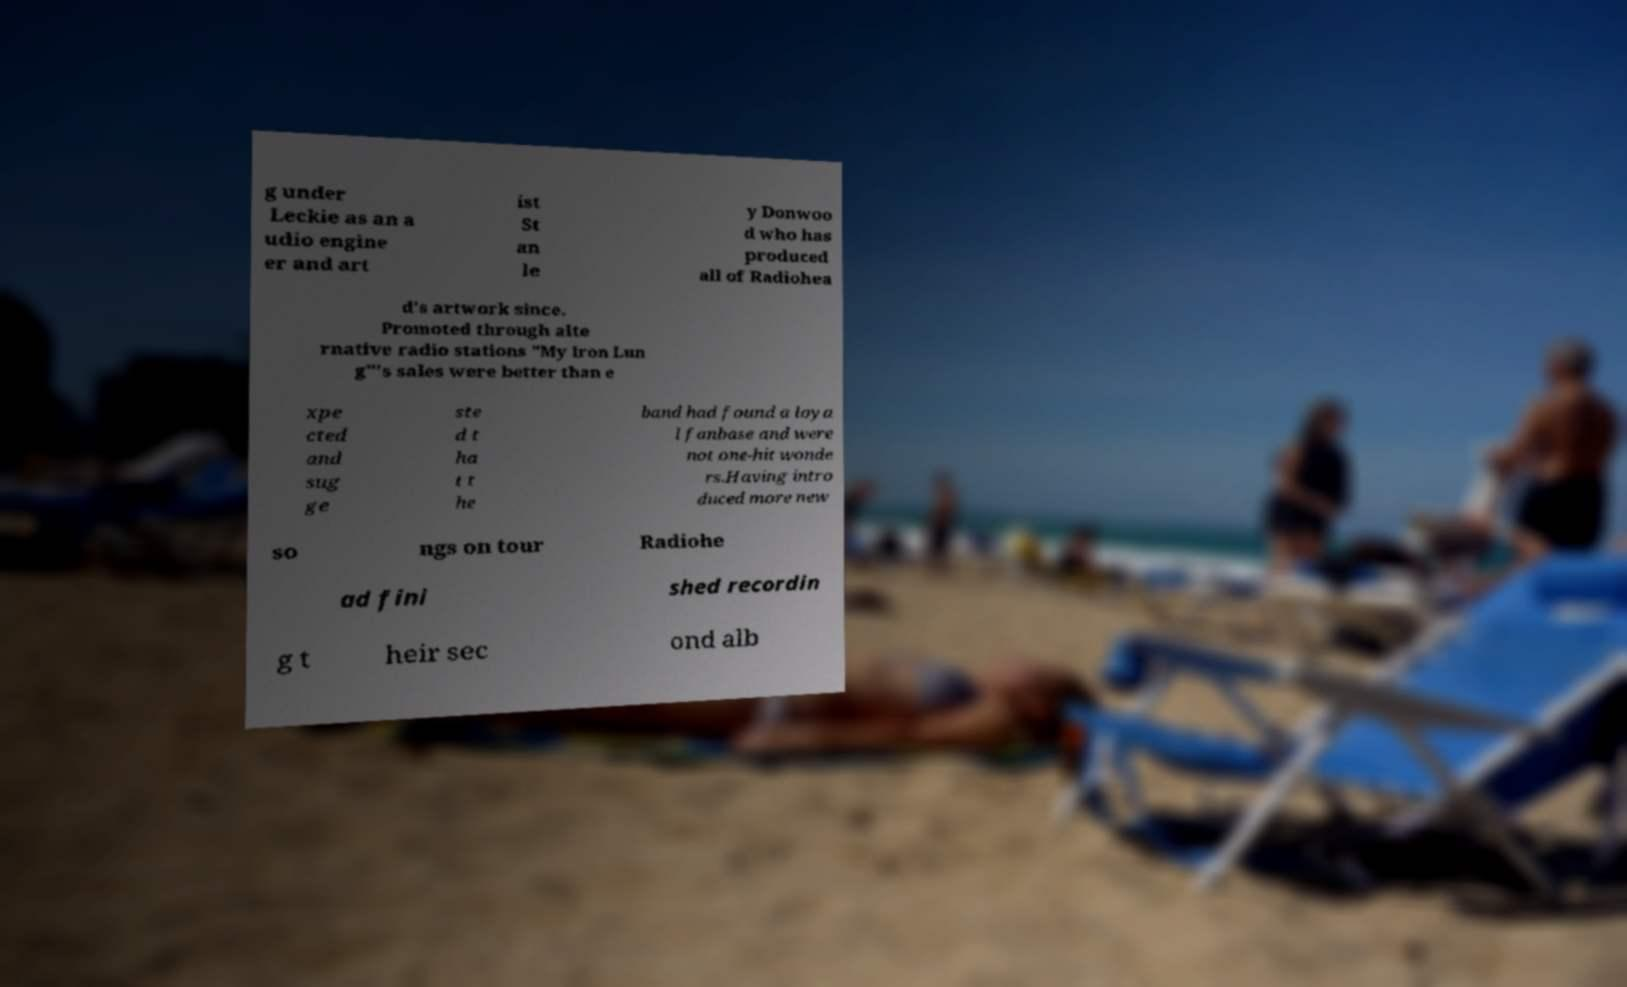For documentation purposes, I need the text within this image transcribed. Could you provide that? g under Leckie as an a udio engine er and art ist St an le y Donwoo d who has produced all of Radiohea d's artwork since. Promoted through alte rnative radio stations "My Iron Lun g"'s sales were better than e xpe cted and sug ge ste d t ha t t he band had found a loya l fanbase and were not one-hit wonde rs.Having intro duced more new so ngs on tour Radiohe ad fini shed recordin g t heir sec ond alb 